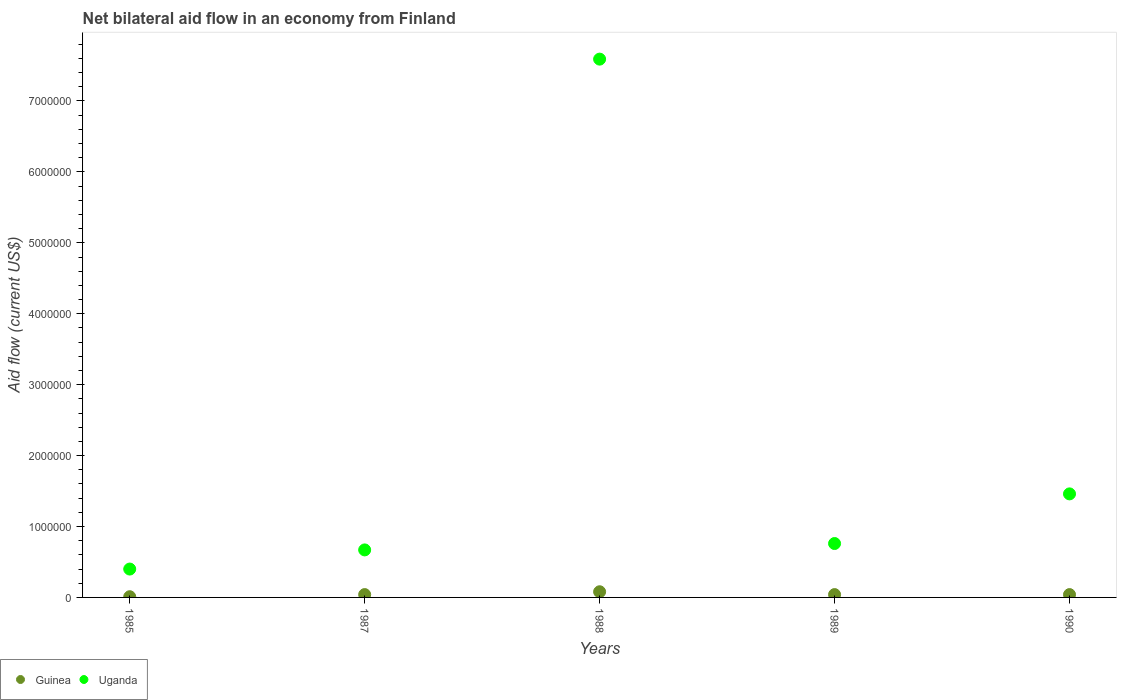How many different coloured dotlines are there?
Make the answer very short. 2. Is the number of dotlines equal to the number of legend labels?
Keep it short and to the point. Yes. What is the net bilateral aid flow in Uganda in 1989?
Keep it short and to the point. 7.60e+05. Across all years, what is the maximum net bilateral aid flow in Uganda?
Offer a very short reply. 7.59e+06. In which year was the net bilateral aid flow in Uganda maximum?
Offer a terse response. 1988. In which year was the net bilateral aid flow in Uganda minimum?
Make the answer very short. 1985. What is the difference between the net bilateral aid flow in Guinea in 1989 and that in 1990?
Your answer should be compact. 0. What is the difference between the net bilateral aid flow in Uganda in 1988 and the net bilateral aid flow in Guinea in 1987?
Give a very brief answer. 7.55e+06. What is the average net bilateral aid flow in Uganda per year?
Provide a succinct answer. 2.18e+06. In the year 1987, what is the difference between the net bilateral aid flow in Guinea and net bilateral aid flow in Uganda?
Give a very brief answer. -6.30e+05. What is the ratio of the net bilateral aid flow in Guinea in 1985 to that in 1987?
Offer a terse response. 0.25. Is the difference between the net bilateral aid flow in Guinea in 1987 and 1988 greater than the difference between the net bilateral aid flow in Uganda in 1987 and 1988?
Your answer should be compact. Yes. What is the difference between the highest and the second highest net bilateral aid flow in Uganda?
Your response must be concise. 6.13e+06. Is the sum of the net bilateral aid flow in Guinea in 1989 and 1990 greater than the maximum net bilateral aid flow in Uganda across all years?
Keep it short and to the point. No. Does the net bilateral aid flow in Guinea monotonically increase over the years?
Provide a succinct answer. No. How many dotlines are there?
Make the answer very short. 2. What is the difference between two consecutive major ticks on the Y-axis?
Your response must be concise. 1.00e+06. Are the values on the major ticks of Y-axis written in scientific E-notation?
Your answer should be compact. No. Where does the legend appear in the graph?
Provide a succinct answer. Bottom left. How many legend labels are there?
Provide a short and direct response. 2. How are the legend labels stacked?
Make the answer very short. Horizontal. What is the title of the graph?
Your answer should be compact. Net bilateral aid flow in an economy from Finland. Does "Poland" appear as one of the legend labels in the graph?
Make the answer very short. No. What is the label or title of the Y-axis?
Provide a short and direct response. Aid flow (current US$). What is the Aid flow (current US$) in Guinea in 1985?
Your answer should be very brief. 10000. What is the Aid flow (current US$) of Guinea in 1987?
Offer a very short reply. 4.00e+04. What is the Aid flow (current US$) of Uganda in 1987?
Offer a very short reply. 6.70e+05. What is the Aid flow (current US$) in Uganda in 1988?
Offer a very short reply. 7.59e+06. What is the Aid flow (current US$) in Guinea in 1989?
Keep it short and to the point. 4.00e+04. What is the Aid flow (current US$) in Uganda in 1989?
Your answer should be compact. 7.60e+05. What is the Aid flow (current US$) of Uganda in 1990?
Ensure brevity in your answer.  1.46e+06. Across all years, what is the maximum Aid flow (current US$) of Uganda?
Ensure brevity in your answer.  7.59e+06. Across all years, what is the minimum Aid flow (current US$) in Uganda?
Your answer should be compact. 4.00e+05. What is the total Aid flow (current US$) of Uganda in the graph?
Offer a very short reply. 1.09e+07. What is the difference between the Aid flow (current US$) in Guinea in 1985 and that in 1987?
Your answer should be compact. -3.00e+04. What is the difference between the Aid flow (current US$) in Uganda in 1985 and that in 1987?
Keep it short and to the point. -2.70e+05. What is the difference between the Aid flow (current US$) of Uganda in 1985 and that in 1988?
Give a very brief answer. -7.19e+06. What is the difference between the Aid flow (current US$) of Uganda in 1985 and that in 1989?
Provide a short and direct response. -3.60e+05. What is the difference between the Aid flow (current US$) in Uganda in 1985 and that in 1990?
Your response must be concise. -1.06e+06. What is the difference between the Aid flow (current US$) in Uganda in 1987 and that in 1988?
Provide a succinct answer. -6.92e+06. What is the difference between the Aid flow (current US$) of Guinea in 1987 and that in 1989?
Your answer should be very brief. 0. What is the difference between the Aid flow (current US$) in Uganda in 1987 and that in 1990?
Your answer should be compact. -7.90e+05. What is the difference between the Aid flow (current US$) of Uganda in 1988 and that in 1989?
Ensure brevity in your answer.  6.83e+06. What is the difference between the Aid flow (current US$) in Guinea in 1988 and that in 1990?
Provide a succinct answer. 4.00e+04. What is the difference between the Aid flow (current US$) in Uganda in 1988 and that in 1990?
Keep it short and to the point. 6.13e+06. What is the difference between the Aid flow (current US$) of Uganda in 1989 and that in 1990?
Keep it short and to the point. -7.00e+05. What is the difference between the Aid flow (current US$) in Guinea in 1985 and the Aid flow (current US$) in Uganda in 1987?
Provide a succinct answer. -6.60e+05. What is the difference between the Aid flow (current US$) of Guinea in 1985 and the Aid flow (current US$) of Uganda in 1988?
Your answer should be compact. -7.58e+06. What is the difference between the Aid flow (current US$) in Guinea in 1985 and the Aid flow (current US$) in Uganda in 1989?
Your answer should be very brief. -7.50e+05. What is the difference between the Aid flow (current US$) in Guinea in 1985 and the Aid flow (current US$) in Uganda in 1990?
Provide a succinct answer. -1.45e+06. What is the difference between the Aid flow (current US$) of Guinea in 1987 and the Aid flow (current US$) of Uganda in 1988?
Offer a very short reply. -7.55e+06. What is the difference between the Aid flow (current US$) of Guinea in 1987 and the Aid flow (current US$) of Uganda in 1989?
Keep it short and to the point. -7.20e+05. What is the difference between the Aid flow (current US$) of Guinea in 1987 and the Aid flow (current US$) of Uganda in 1990?
Offer a terse response. -1.42e+06. What is the difference between the Aid flow (current US$) in Guinea in 1988 and the Aid flow (current US$) in Uganda in 1989?
Your answer should be compact. -6.80e+05. What is the difference between the Aid flow (current US$) in Guinea in 1988 and the Aid flow (current US$) in Uganda in 1990?
Provide a short and direct response. -1.38e+06. What is the difference between the Aid flow (current US$) of Guinea in 1989 and the Aid flow (current US$) of Uganda in 1990?
Give a very brief answer. -1.42e+06. What is the average Aid flow (current US$) of Guinea per year?
Offer a terse response. 4.20e+04. What is the average Aid flow (current US$) of Uganda per year?
Your answer should be compact. 2.18e+06. In the year 1985, what is the difference between the Aid flow (current US$) in Guinea and Aid flow (current US$) in Uganda?
Provide a succinct answer. -3.90e+05. In the year 1987, what is the difference between the Aid flow (current US$) of Guinea and Aid flow (current US$) of Uganda?
Your answer should be very brief. -6.30e+05. In the year 1988, what is the difference between the Aid flow (current US$) in Guinea and Aid flow (current US$) in Uganda?
Offer a terse response. -7.51e+06. In the year 1989, what is the difference between the Aid flow (current US$) of Guinea and Aid flow (current US$) of Uganda?
Your answer should be compact. -7.20e+05. In the year 1990, what is the difference between the Aid flow (current US$) of Guinea and Aid flow (current US$) of Uganda?
Your answer should be very brief. -1.42e+06. What is the ratio of the Aid flow (current US$) of Uganda in 1985 to that in 1987?
Your answer should be very brief. 0.6. What is the ratio of the Aid flow (current US$) in Uganda in 1985 to that in 1988?
Offer a terse response. 0.05. What is the ratio of the Aid flow (current US$) in Uganda in 1985 to that in 1989?
Your answer should be very brief. 0.53. What is the ratio of the Aid flow (current US$) of Guinea in 1985 to that in 1990?
Your answer should be very brief. 0.25. What is the ratio of the Aid flow (current US$) in Uganda in 1985 to that in 1990?
Offer a very short reply. 0.27. What is the ratio of the Aid flow (current US$) in Uganda in 1987 to that in 1988?
Offer a very short reply. 0.09. What is the ratio of the Aid flow (current US$) of Uganda in 1987 to that in 1989?
Provide a short and direct response. 0.88. What is the ratio of the Aid flow (current US$) of Guinea in 1987 to that in 1990?
Your answer should be very brief. 1. What is the ratio of the Aid flow (current US$) in Uganda in 1987 to that in 1990?
Ensure brevity in your answer.  0.46. What is the ratio of the Aid flow (current US$) of Uganda in 1988 to that in 1989?
Your answer should be compact. 9.99. What is the ratio of the Aid flow (current US$) of Uganda in 1988 to that in 1990?
Offer a very short reply. 5.2. What is the ratio of the Aid flow (current US$) of Guinea in 1989 to that in 1990?
Make the answer very short. 1. What is the ratio of the Aid flow (current US$) in Uganda in 1989 to that in 1990?
Keep it short and to the point. 0.52. What is the difference between the highest and the second highest Aid flow (current US$) in Guinea?
Offer a very short reply. 4.00e+04. What is the difference between the highest and the second highest Aid flow (current US$) of Uganda?
Offer a very short reply. 6.13e+06. What is the difference between the highest and the lowest Aid flow (current US$) in Guinea?
Offer a terse response. 7.00e+04. What is the difference between the highest and the lowest Aid flow (current US$) in Uganda?
Offer a terse response. 7.19e+06. 